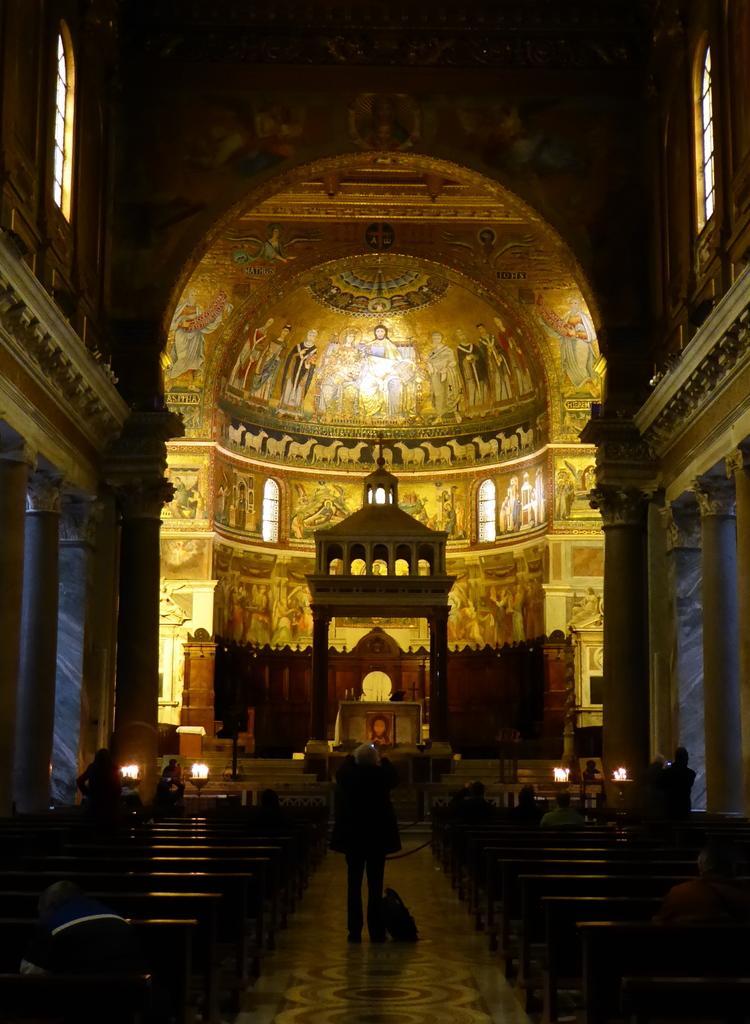How would you summarize this image in a sentence or two? This is an inside view of a church. In this picture we can see painting on the walls. We can see pillars, lights, benches, objects and windows. In the middle portion of the picture we can see a man standing. There is a bag on the floor. 